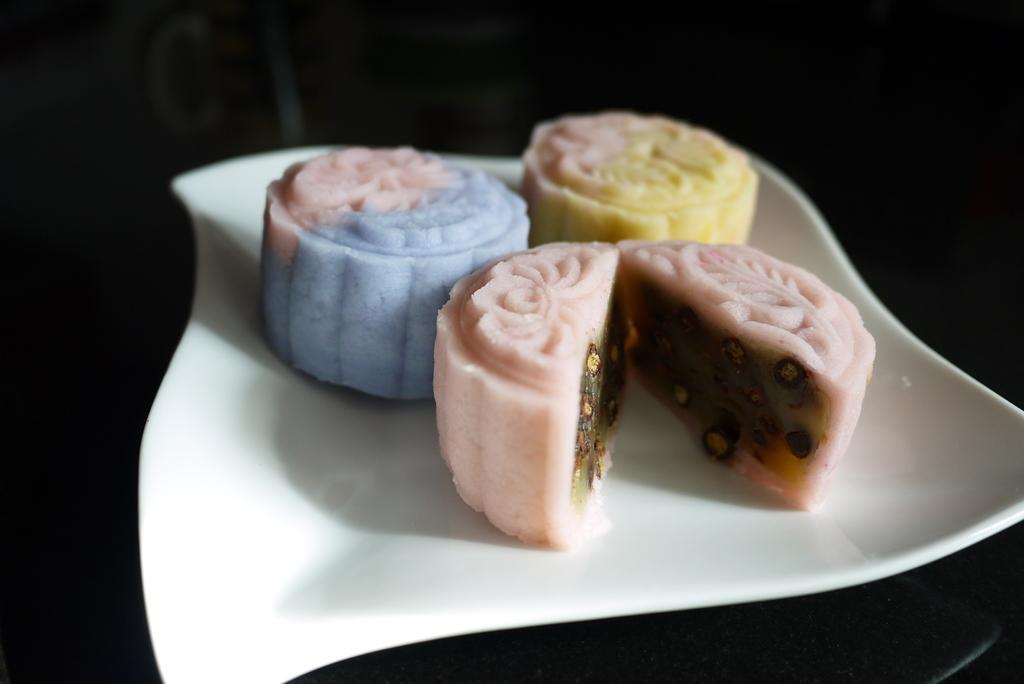What is present on the plate in the image? There are food items served on a plate in the image. What type of mint can be seen growing near the plate in the image? There is no mint present in the image; it only shows food items served on a plate. Can you describe the toad that is sitting on the plate in the image? There is no toad present in the image; it only shows food items served on a plate. 